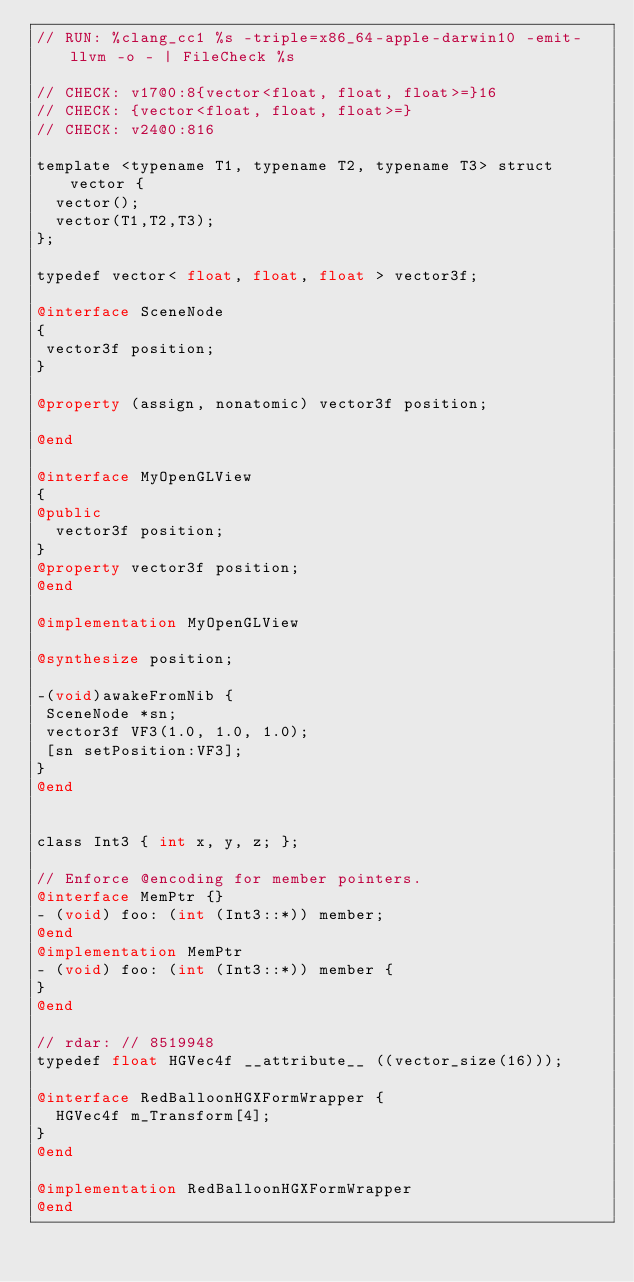Convert code to text. <code><loc_0><loc_0><loc_500><loc_500><_ObjectiveC_>// RUN: %clang_cc1 %s -triple=x86_64-apple-darwin10 -emit-llvm -o - | FileCheck %s

// CHECK: v17@0:8{vector<float, float, float>=}16
// CHECK: {vector<float, float, float>=}
// CHECK: v24@0:816

template <typename T1, typename T2, typename T3> struct vector {
  vector();
  vector(T1,T2,T3);
};

typedef vector< float, float, float > vector3f;

@interface SceneNode
{
 vector3f position;
}

@property (assign, nonatomic) vector3f position;

@end

@interface MyOpenGLView
{
@public
  vector3f position;
}
@property vector3f position;
@end

@implementation MyOpenGLView

@synthesize position;

-(void)awakeFromNib {
 SceneNode *sn;
 vector3f VF3(1.0, 1.0, 1.0);
 [sn setPosition:VF3];
}
@end


class Int3 { int x, y, z; };

// Enforce @encoding for member pointers.
@interface MemPtr {}
- (void) foo: (int (Int3::*)) member;
@end
@implementation MemPtr
- (void) foo: (int (Int3::*)) member {
}
@end

// rdar: // 8519948
typedef float HGVec4f __attribute__ ((vector_size(16)));

@interface RedBalloonHGXFormWrapper {
  HGVec4f m_Transform[4];
}
@end

@implementation RedBalloonHGXFormWrapper
@end

</code> 